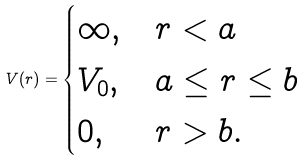<formula> <loc_0><loc_0><loc_500><loc_500>V ( r ) = \begin{cases} \infty , & r < a \\ V _ { 0 } , & a \leq r \leq b \\ 0 , & r > b . \end{cases}</formula> 